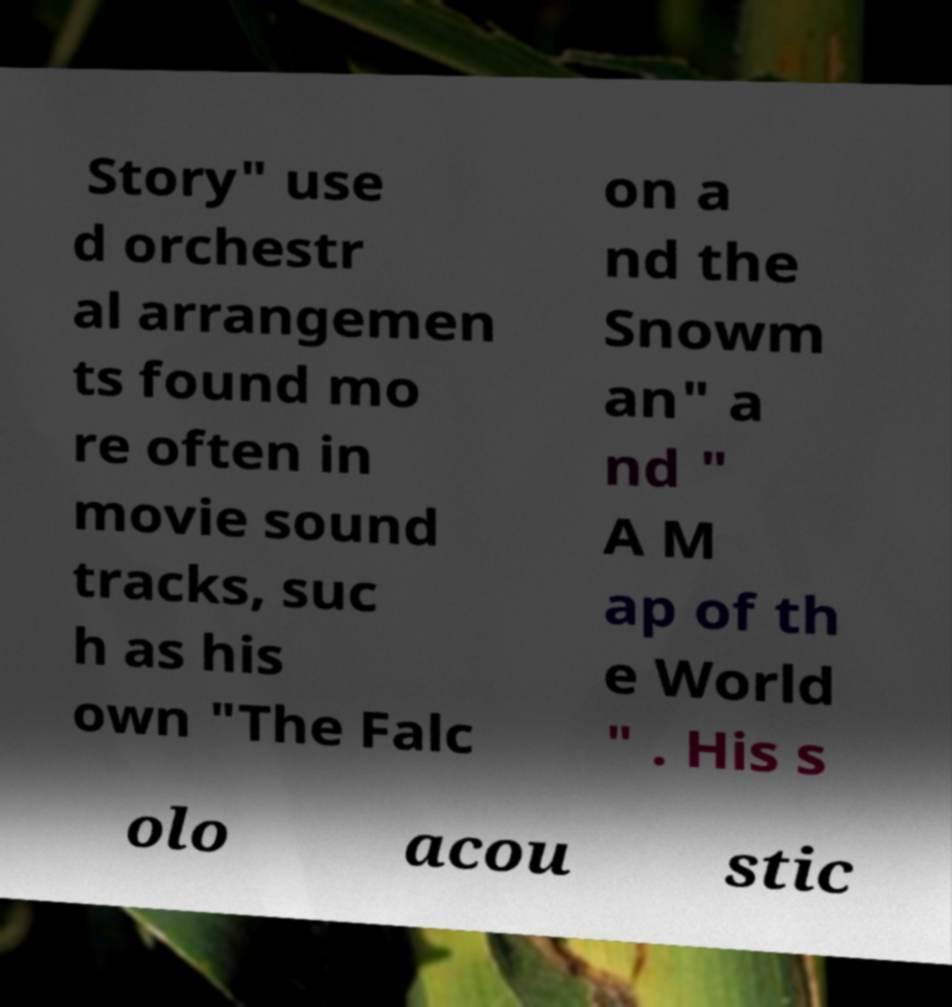Can you accurately transcribe the text from the provided image for me? Story" use d orchestr al arrangemen ts found mo re often in movie sound tracks, suc h as his own "The Falc on a nd the Snowm an" a nd " A M ap of th e World " . His s olo acou stic 